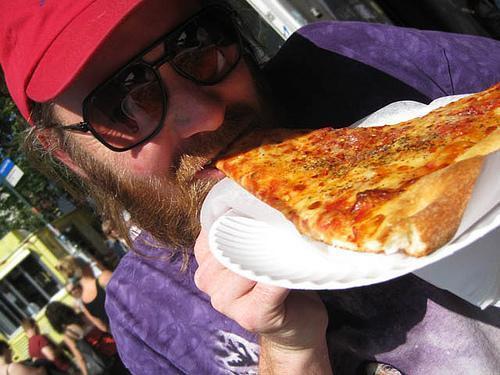How many people are in the picture?
Give a very brief answer. 2. How many bears are in this image?
Give a very brief answer. 0. 